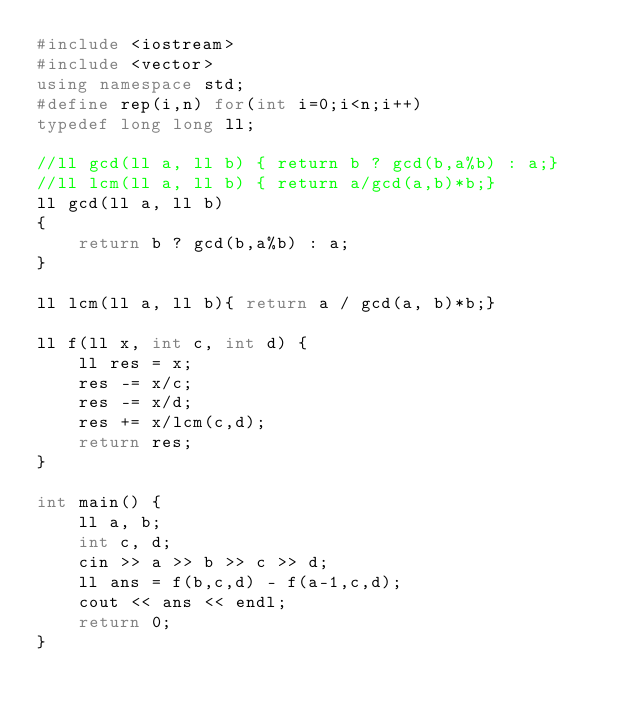Convert code to text. <code><loc_0><loc_0><loc_500><loc_500><_C++_>#include <iostream>
#include <vector>
using namespace std;
#define rep(i,n) for(int i=0;i<n;i++)
typedef long long ll;

//ll gcd(ll a, ll b) { return b ? gcd(b,a%b) : a;}
//ll lcm(ll a, ll b) { return a/gcd(a,b)*b;}
ll gcd(ll a, ll b)
{
    return b ? gcd(b,a%b) : a;
}

ll lcm(ll a, ll b){ return a / gcd(a, b)*b;}

ll f(ll x, int c, int d) {
    ll res = x;
    res -= x/c;
    res -= x/d;
    res += x/lcm(c,d);
    return res;
}

int main() {
    ll a, b;
    int c, d;
    cin >> a >> b >> c >> d;
    ll ans = f(b,c,d) - f(a-1,c,d);
    cout << ans << endl;
    return 0;
}</code> 